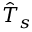<formula> <loc_0><loc_0><loc_500><loc_500>\hat { T } _ { s }</formula> 